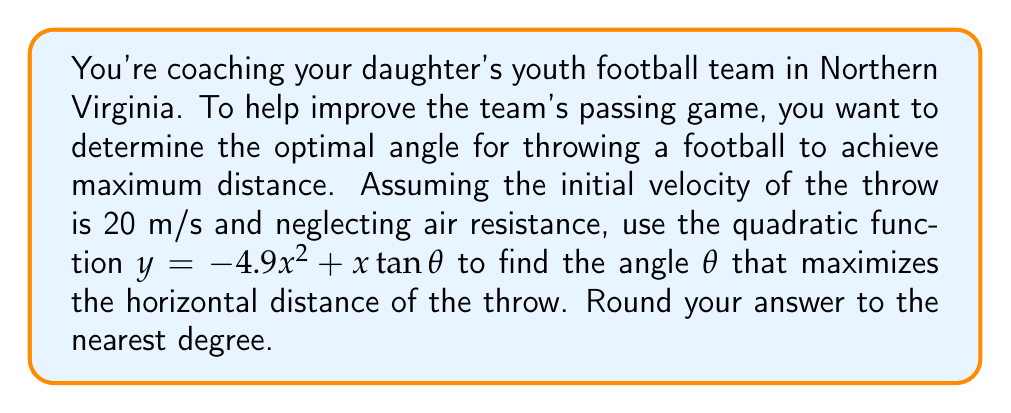Solve this math problem. To solve this problem, we'll follow these steps:

1) The horizontal distance is maximized when $y = 0$ (the ball hits the ground). We need to find the positive root of the quadratic equation:

   $0 = -4.9x^2 + x\tan\theta$

2) The quadratic formula gives us:

   $x = \frac{-b \pm \sqrt{b^2 - 4ac}}{2a}$

   Where $a = -4.9$, $b = \tan\theta$, and $c = 0$

3) Simplifying:

   $x = \frac{\tan\theta \pm \sqrt{\tan^2\theta}}{-9.8} = \frac{\tan\theta}{-4.9} \pm \frac{\tan\theta}{-4.9}$

4) The positive root (maximum distance) is:

   $x = \frac{2\tan\theta}{4.9}$

5) We know that $x = v_0^2\sin(2\theta)/g$ for projectile motion, where $v_0$ is the initial velocity and $g$ is gravitational acceleration (9.8 m/s^2).

6) Equating these:

   $\frac{2\tan\theta}{4.9} = \frac{20^2\sin(2\theta)}{9.8}$

7) Simplifying:

   $\tan\theta = 20\sin(2\theta)$

8) Using the identity $\sin(2\theta) = 2\sin\theta\cos\theta$:

   $\tan\theta = 40\sin\theta\cos\theta$

9) Dividing both sides by $\cos\theta$:

   $\sin\theta = 40\sin\theta\cos^2\theta$

10) Simplifying:

    $1 = 40\cos^2\theta$

11) Solving for $\theta$:

    $\cos\theta = \frac{1}{\sqrt{40}} = \frac{1}{2\sqrt{10}}$

    $\theta = \arccos(\frac{1}{2\sqrt{10}}) \approx 45°$

Therefore, the optimal angle for the throw is approximately 45°.
Answer: 45° 